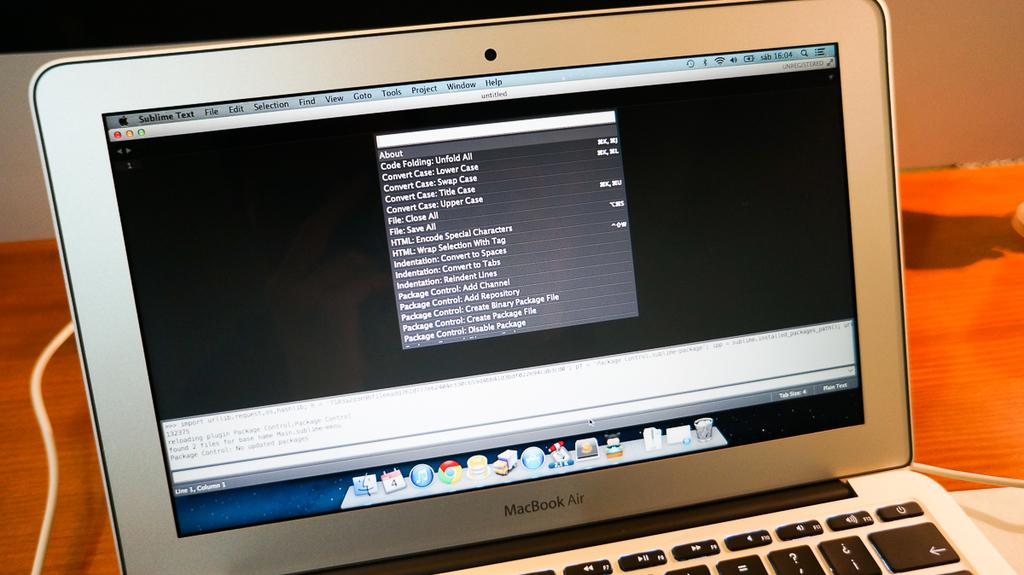<image>
Give a short and clear explanation of the subsequent image. macbook air laptop with the lid open and a list of files on the desktop 